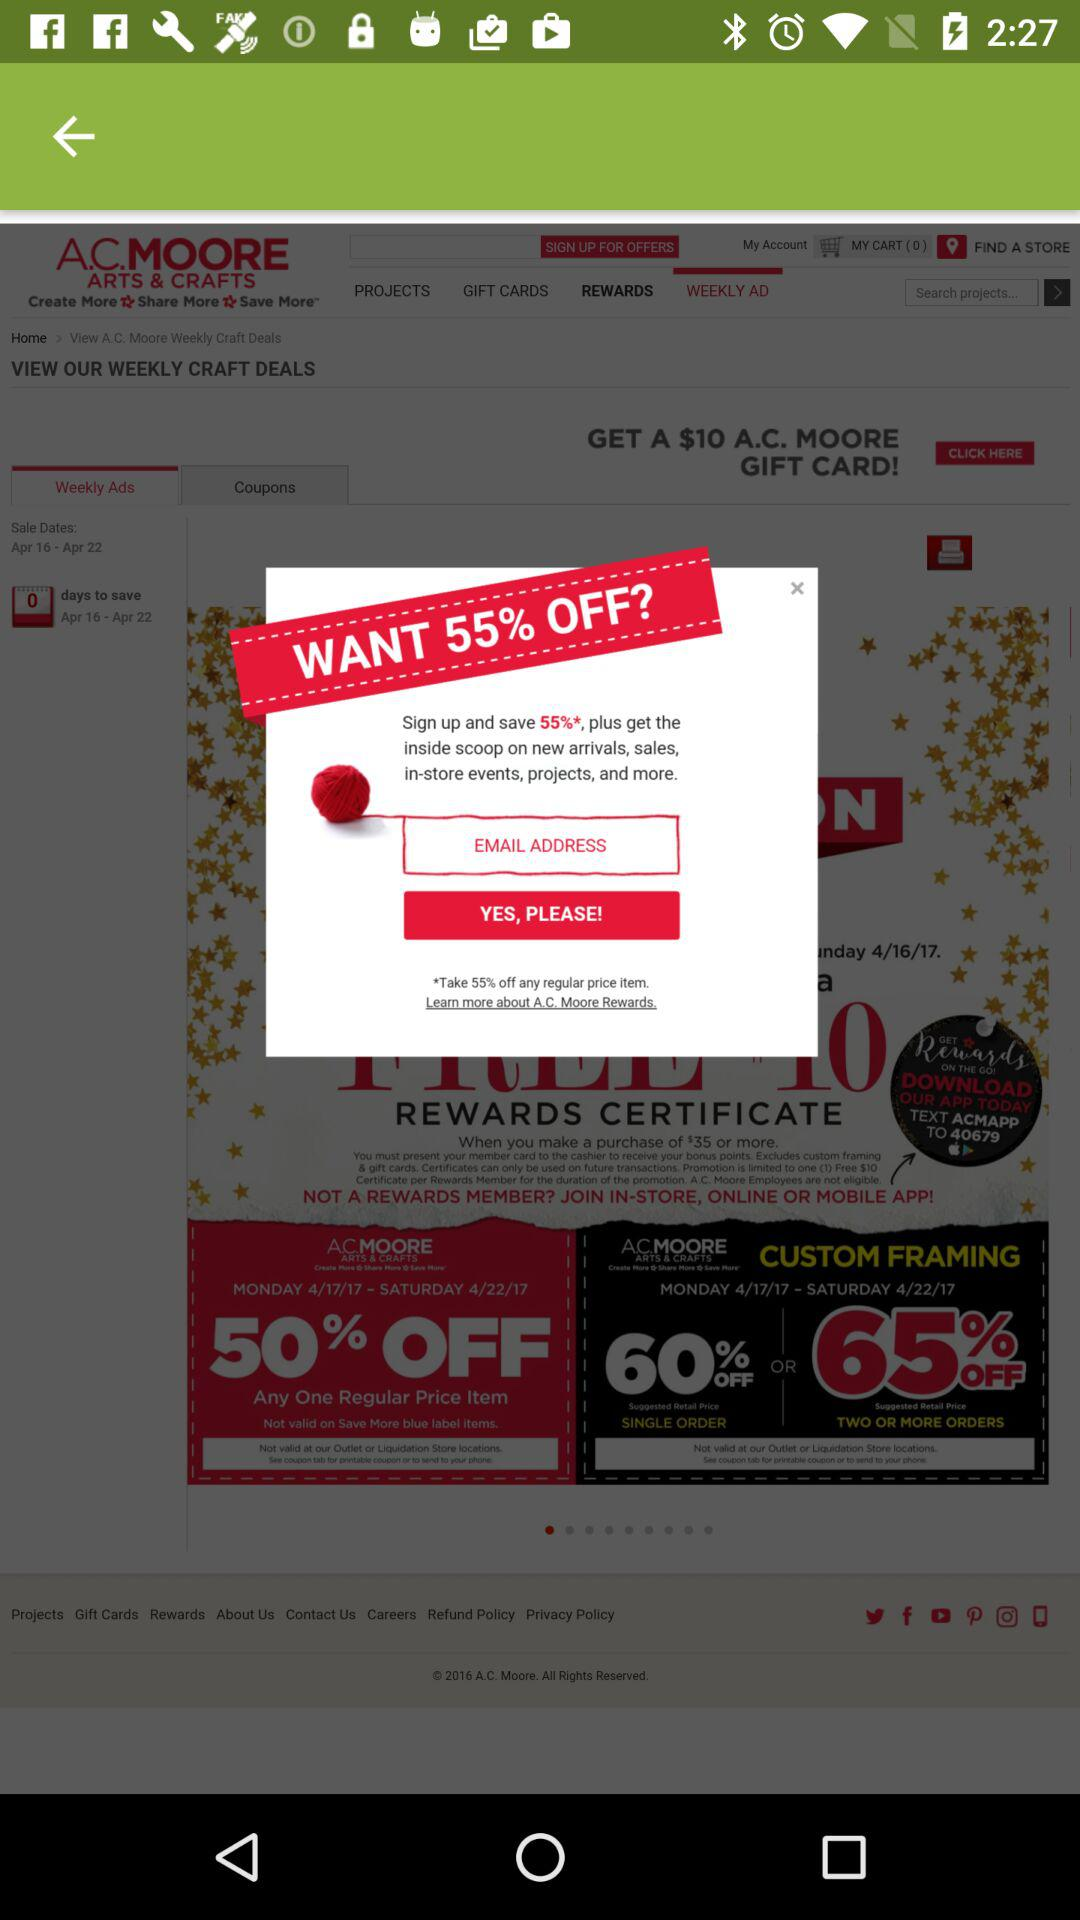How much are the gift cards?
When the provided information is insufficient, respond with <no answer>. <no answer> 